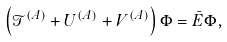<formula> <loc_0><loc_0><loc_500><loc_500>\left ( { \mathcal { T } } ^ { ( A ) } + U ^ { ( A ) } + V ^ { ( A ) } \right ) \Phi = \bar { E } \Phi ,</formula> 